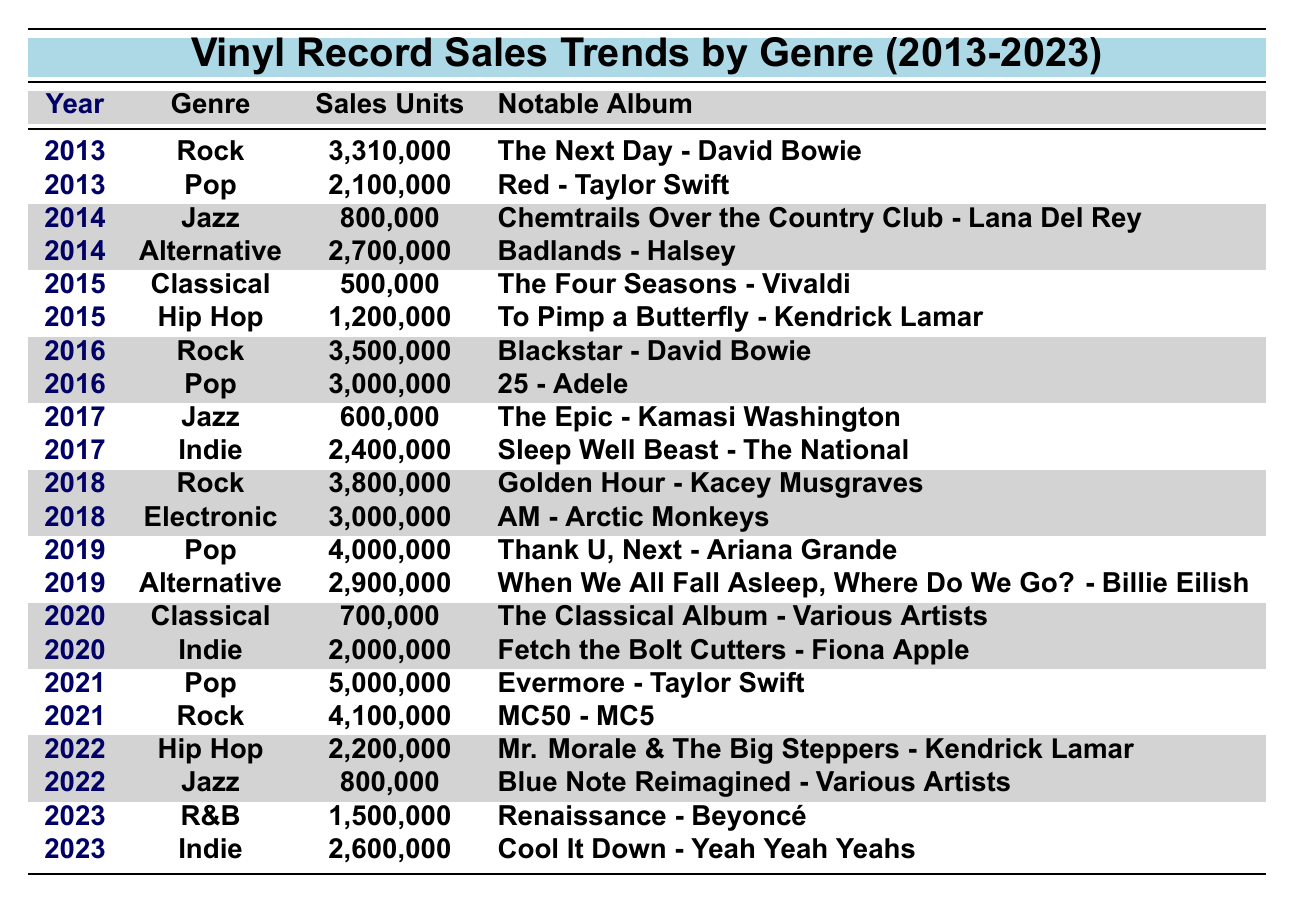What year had the highest vinyl sales in the Rock genre? By scanning the table for the Rock genre, the highest sales were in 2018 with 3,800,000 units sold.
Answer: 2018 In which year did Classical vinyl sales peak? The table indicates that Classical sales reached their peak in 2020, with 700,000 units sold.
Answer: 2020 What is the total vinyl sales for Pop across all years listed? The total sales for Pop can be calculated as follows: 2,100,000 (2013) + 3,000,000 (2016) + 4,000,000 (2019) + 5,000,000 (2021) = 14,100,000.
Answer: 14,100,000 Which genre saw a decrease in sales from 2016 to 2017? The table shows that Jazz sales decreased from 800,000 in 2014 and then to 600,000 in 2017, confirming a downward trend.
Answer: Jazz Was there any year in which both Rock and Pop achieved sales over 3 million? Yes, both genres exceeded 3 million sales in 2016 and 2018 based on the data provided in the table.
Answer: Yes What is the difference in sales between Pop in 2021 and Jazz in 2022? Pop sales in 2021 were 5,000,000 and Jazz in 2022 were 800,000. The difference is 5,000,000 - 800,000 = 4,200,000.
Answer: 4,200,000 Identify the notable album that corresponds to the highest sales in the Indie genre. Referring to the Indie genre total sales across years, 2,600,000 in 2023 correlates with "Cool It Down - Yeah Yeah Yeahs."
Answer: Cool It Down - Yeah Yeah Yeahs Which genre had the least sales in 2015? In 2015, Classical had the least sales at 500,000, as seen in the table.
Answer: Classical What percentage of sales in 2019 came from the Pop genre compared to the total sales for that year? Total sales in 2019 were 4,000,000 (Pop) + 2,900,000 (Alternative) = 6,900,000. The percentage of Pop sales is (4,000,000 / 6,900,000) * 100 = 57.97%, approximately 58%.
Answer: 58% Which year had the highest total sales across all genres? Analyzing the yearly sales: 2013 (5,410,000), 2014 (3,500,000), 2015 (1,700,000), 2016 (6,500,000), 2017 (3,000,000), 2018 (6,800,000), 2019 (6,900,000), 2020 (2,700,000), 2021 (9,100,000), 2022 (3,000,000), and 2023 (3,100,000); the highest was in 2021.
Answer: 2021 